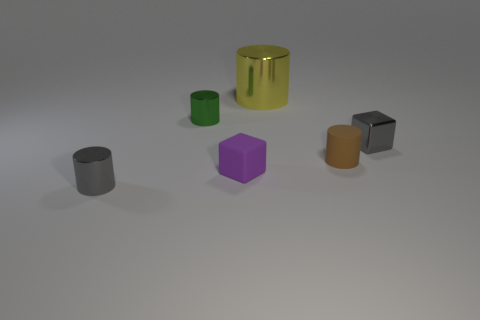Subtract all small brown cylinders. How many cylinders are left? 3 Add 3 green rubber things. How many objects exist? 9 Subtract all green cylinders. How many cylinders are left? 3 Subtract all cubes. How many objects are left? 4 Subtract 3 cylinders. How many cylinders are left? 1 Subtract all purple rubber objects. Subtract all big red rubber things. How many objects are left? 5 Add 5 tiny shiny cylinders. How many tiny shiny cylinders are left? 7 Add 2 small gray objects. How many small gray objects exist? 4 Subtract 1 yellow cylinders. How many objects are left? 5 Subtract all red cylinders. Subtract all green spheres. How many cylinders are left? 4 